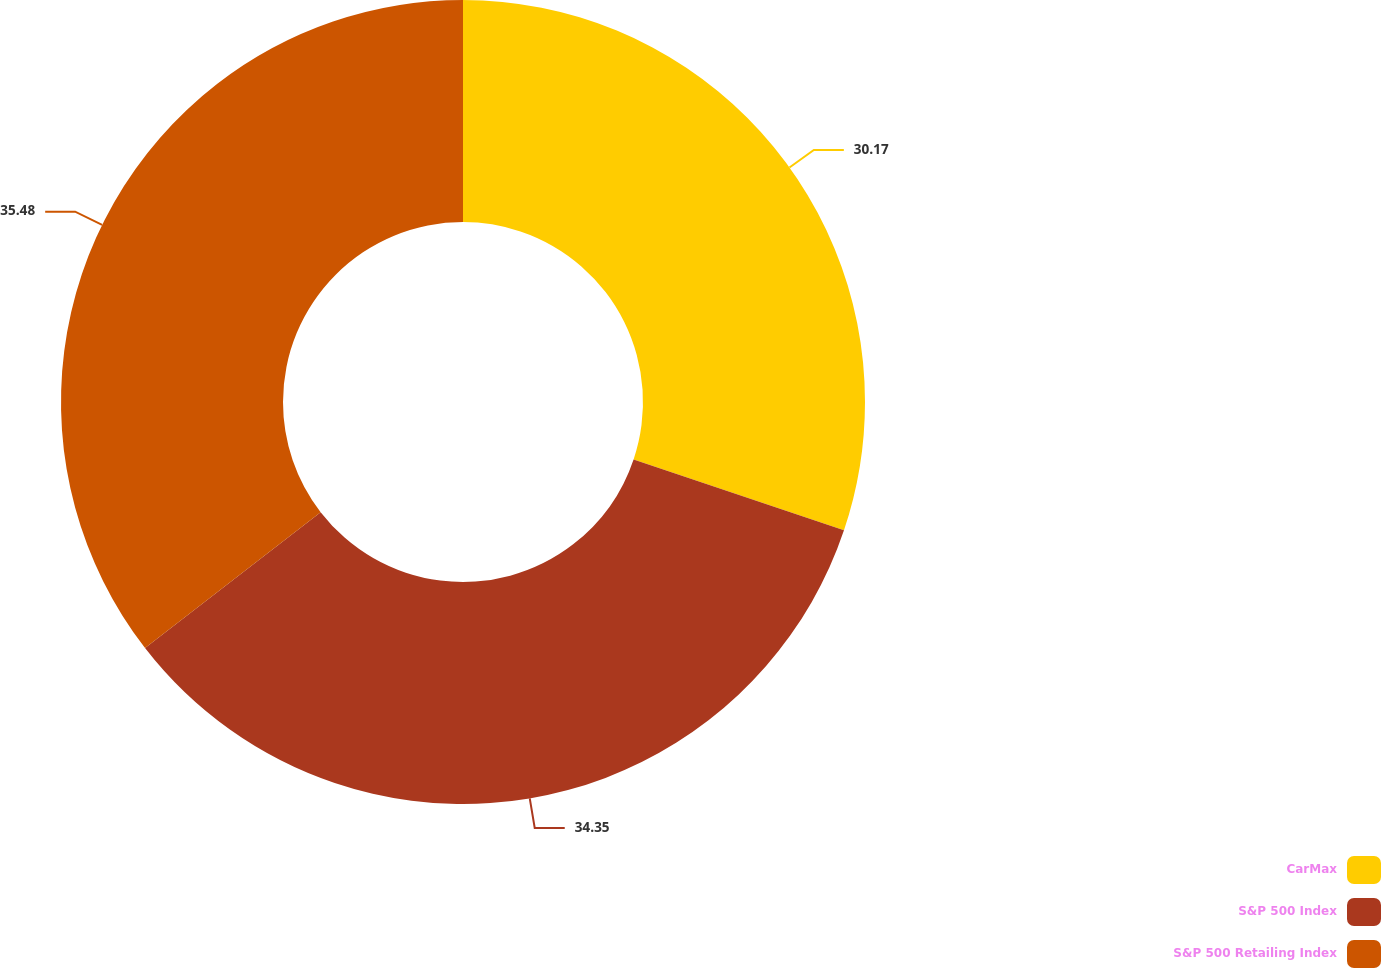Convert chart to OTSL. <chart><loc_0><loc_0><loc_500><loc_500><pie_chart><fcel>CarMax<fcel>S&P 500 Index<fcel>S&P 500 Retailing Index<nl><fcel>30.17%<fcel>34.35%<fcel>35.48%<nl></chart> 